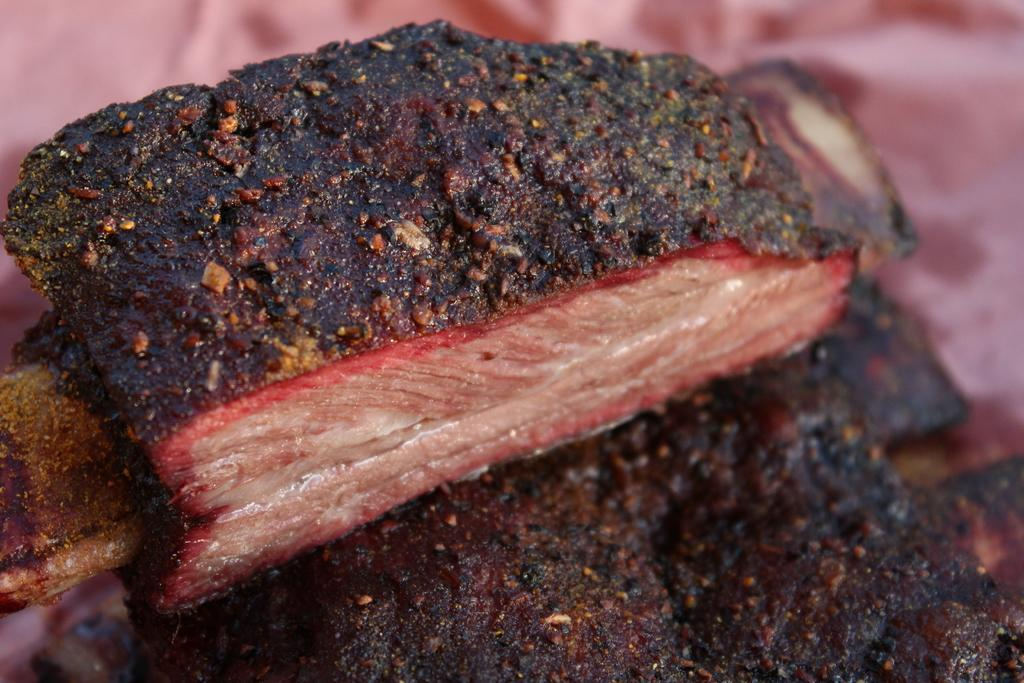What type of food is visible in the image? There is a piece of cooked meat in the image. Can you describe the background of the image? The background of the image appears blurry. What type of shoe can be seen in the image? There is no shoe present in the image. Can you describe the smile of the person in the image? There is no person present in the image, so there is no smile to describe. 